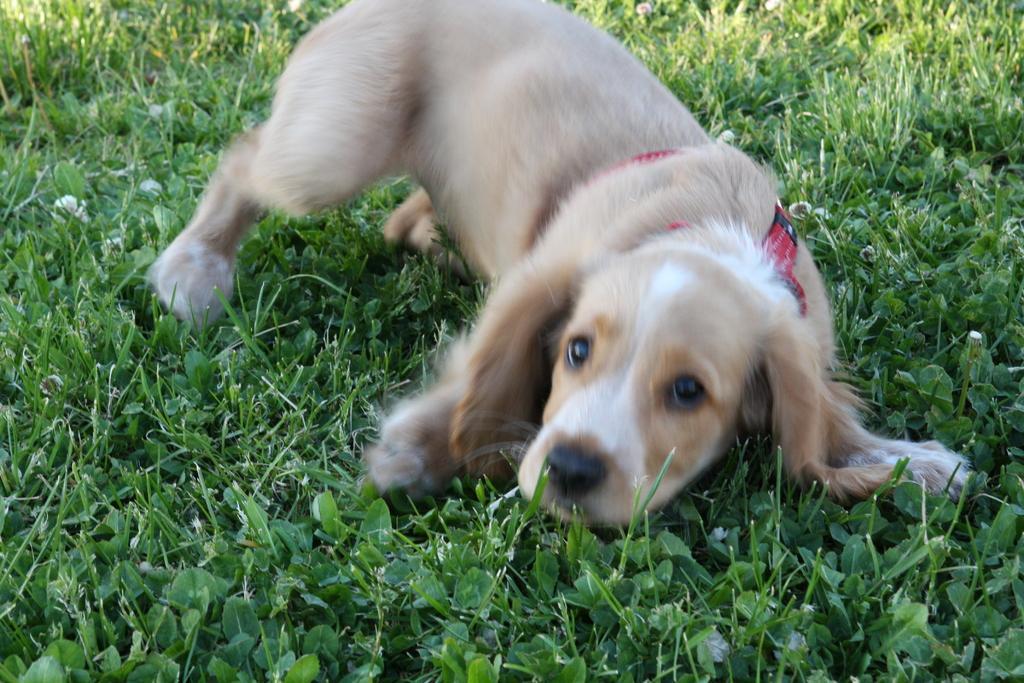Can you describe this image briefly? In this image I can see an animal in white and cream color and the grass is in green color. 